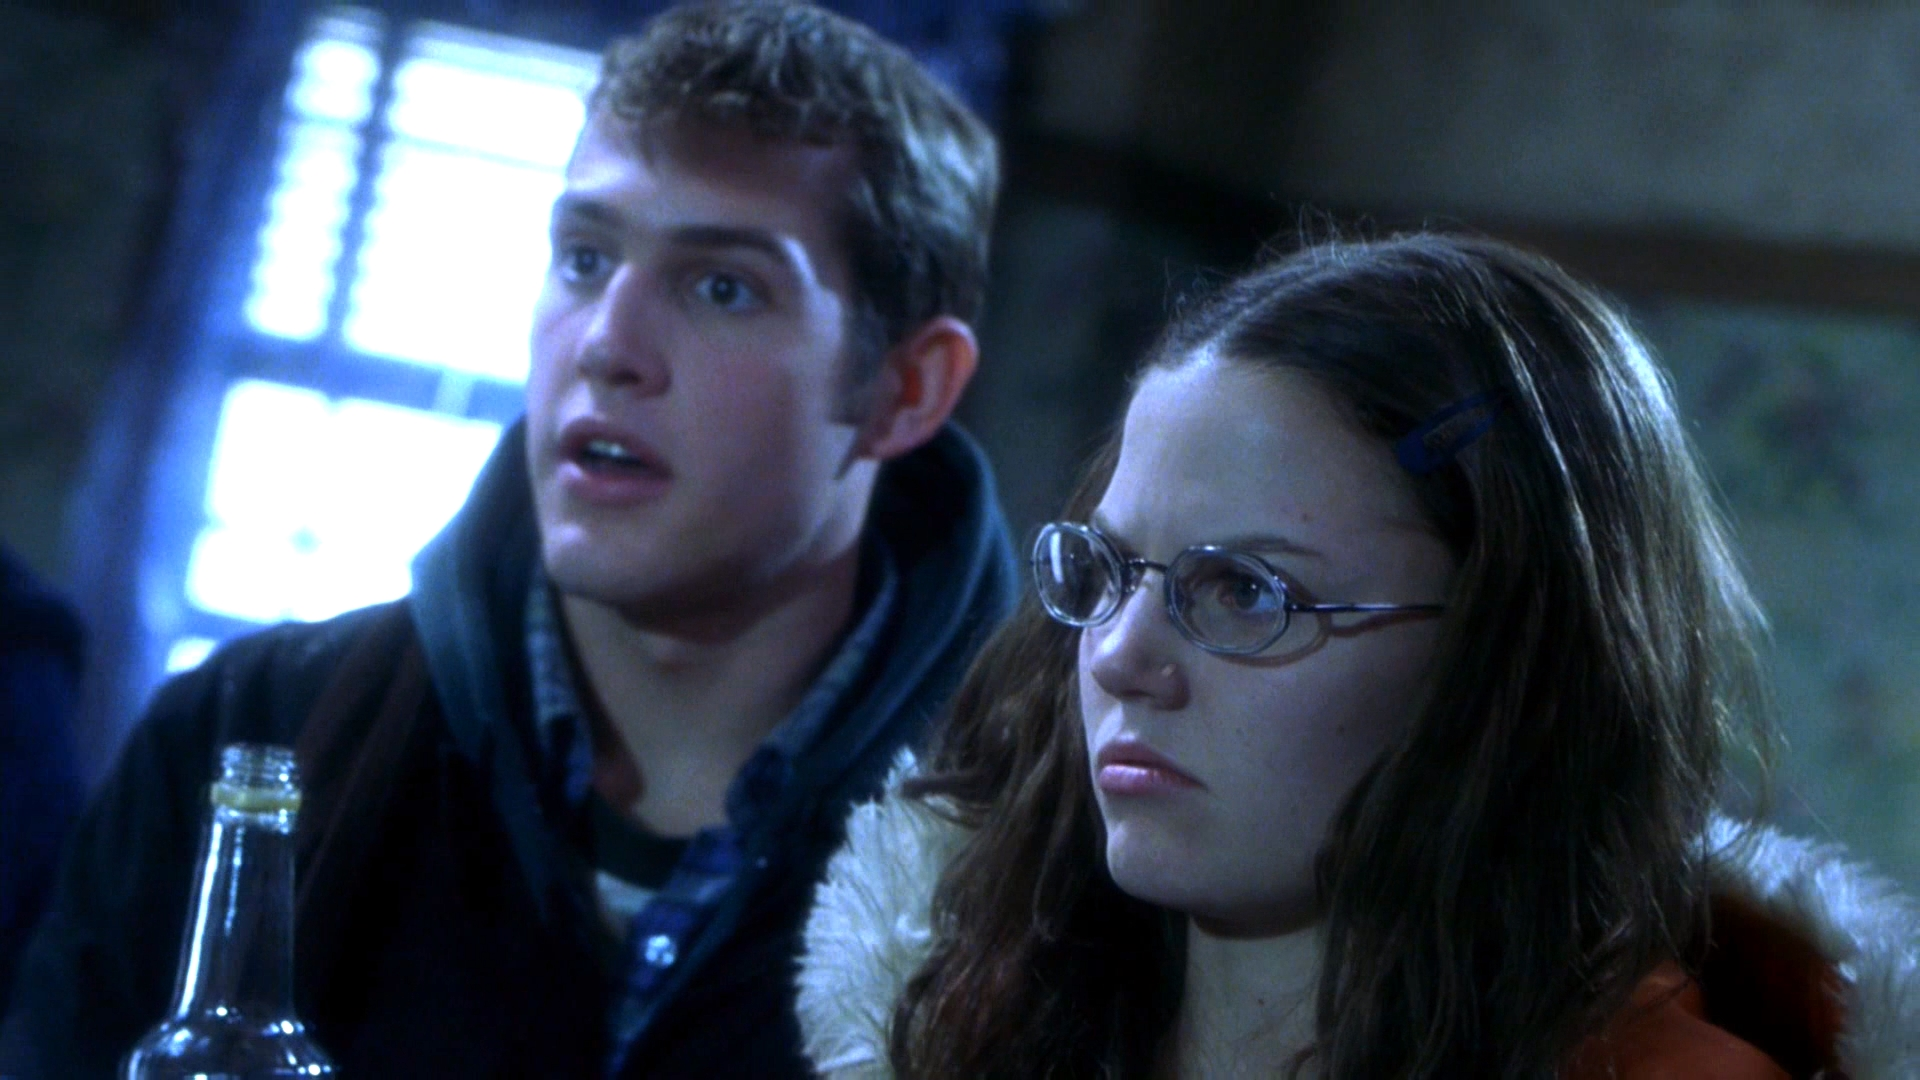Imagine if this scene was set in a fantasy world, what kind of creatures or elements could be in the background? If this scene were set in a fantasy world, the window behind them could lead to an enchanted forest illuminated by bioluminescent plants. Ethereal creatures such as fairies with shimmering wings and mischievous forest sprites might be peeking in. The bottle in the woman's hand could be a potion, glowing faintly with magical energy. The characters could be preparing for an encounter with a mystical beast or on a quest to find an ancient relic. I see, can you describe a potential story plot involving these two individuals in the fantasy setting? In a fantastical realm, the woman, a skilled alchemist named Elara, and the man, her loyal companion and protector, Rowan, are on a daring quest to retrieve the Heartstone—a legendary gem said to possess the power to heal their war-torn world. They have just deciphered a cryptic map that points to the Heartstone’s location inside the Enchanted Forest, a place teeming with magical creatures and ancient spells. As night falls, they prepare a potion designed to repel dark forces. Suddenly, they witness an eerie yet captivating spectacle: the emergence of luminescent fairies, who might guide them or lead them astray. The shock and determination on their faces reflect the gravity of their mission and the unknown challenges they are about to face. Could you provide a very creative twist to this fantasy plot? Just as Elara and Rowan step into the Enchanted Forest, they encounter a mischievous spirit bound by an ancient curse. This spirit, once a noble guardian of the forest, reveals that the Heartstone they seek is not a gem but a sentient being with its own will and desires. The Heartstone, capable of granting immense power, has guarded itself against those unworthy by transforming into whoever attempts to harness it. Elara and Rowan must prove their worth not through might or magical prowess, but through empathy, wisdom, and selflessness. Along the way, they uncover a forgotten prophecy that ties their fates directly to the future of the entire realm, urging them to reconcile with long-lost kin and accept their intertwined destinies. Given the expressions and tension in the image, what might be a realistic scenario that matches those elements? A realistic scenario matching the expressions and tension in the image could involve the two individuals discovering a crucial piece of evidence in a high-stakes investigation. They might be undercover journalists or detectives who have just stumbled upon a shocking secret that could expose a grand conspiracy. The bottle could be a container of vital evidence, and their expressions reflect the weight of the revelation and the urgency to act quickly, knowing they are now targets of those who wish to keep the secret hidden. What could be a shorter, more to-the-point realistic situation for these characters? The individuals might be college students who have just discovered an urgent news update on their phones about a local emergency. The bottle is simply a drink, but their expressions reflect their immediate concern and disbelief as they process the shocking news together. 